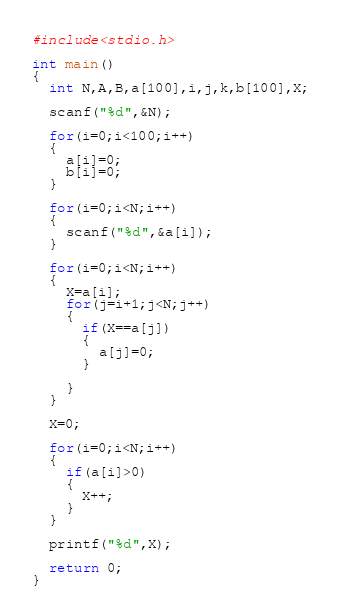Convert code to text. <code><loc_0><loc_0><loc_500><loc_500><_C_>#include<stdio.h>

int main()
{
  int N,A,B,a[100],i,j,k,b[100],X;
 
  scanf("%d",&N);

  for(i=0;i<100;i++)
  {
    a[i]=0;
    b[i]=0;    
  }
  
  for(i=0;i<N;i++)
  {
    scanf("%d",&a[i]);
  }
  
  for(i=0;i<N;i++)
  {
    X=a[i];
    for(j=i+1;j<N;j++)
    {
      if(X==a[j])
      {
        a[j]=0;
      }
      
    }
  }
  
  X=0;
  
  for(i=0;i<N;i++)
  {
    if(a[i]>0)
    {
      X++;
    }    
  }
  
  printf("%d",X);
  
  return 0;
}</code> 